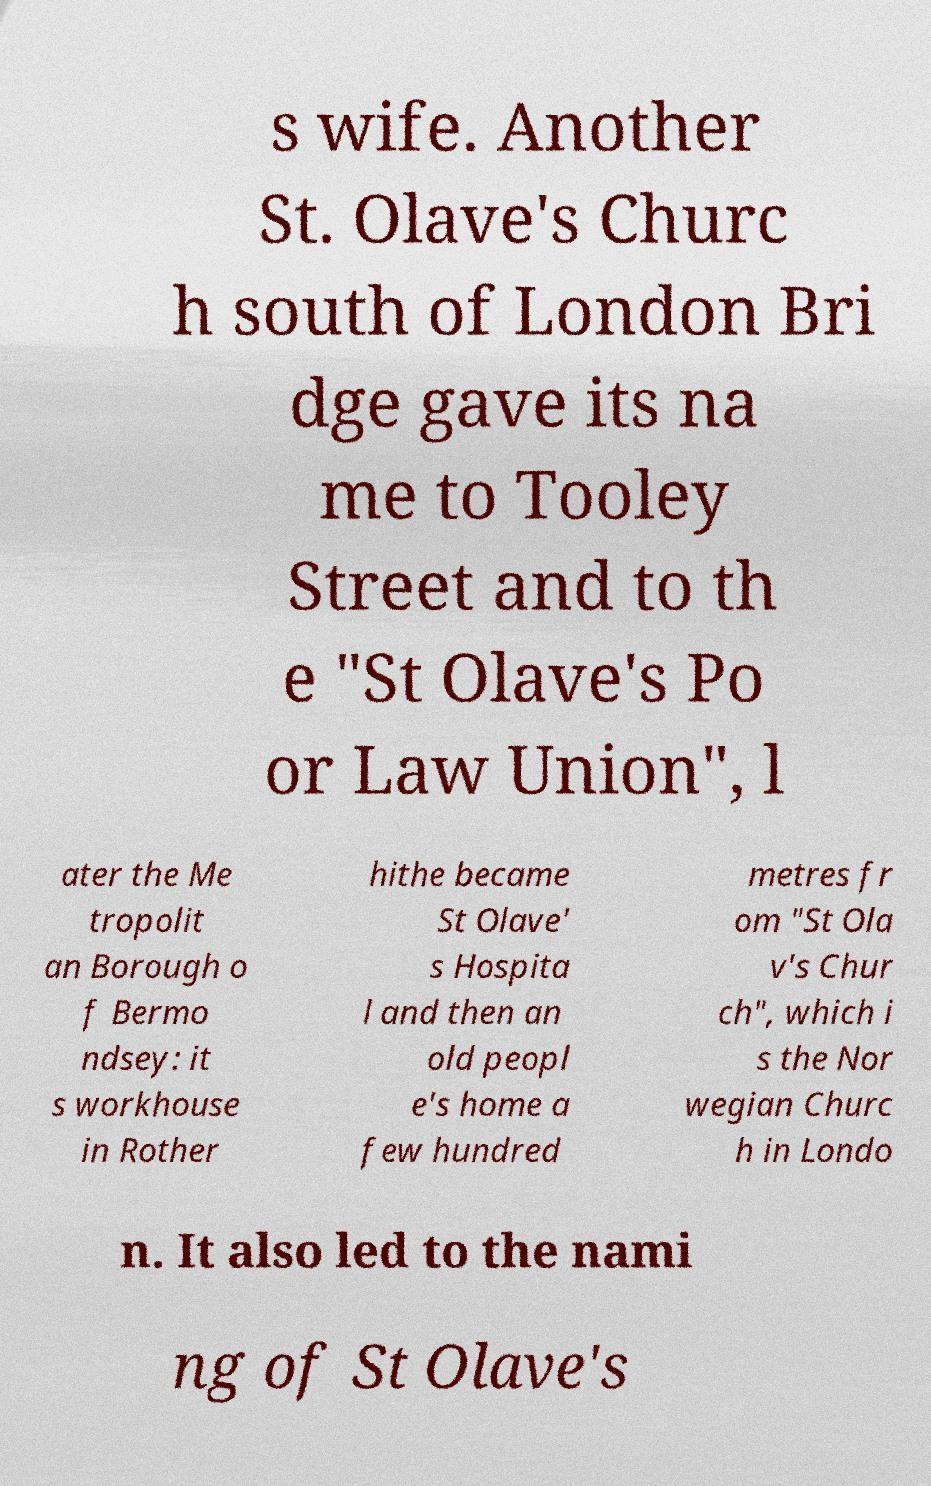Please identify and transcribe the text found in this image. s wife. Another St. Olave's Churc h south of London Bri dge gave its na me to Tooley Street and to th e "St Olave's Po or Law Union", l ater the Me tropolit an Borough o f Bermo ndsey: it s workhouse in Rother hithe became St Olave' s Hospita l and then an old peopl e's home a few hundred metres fr om "St Ola v's Chur ch", which i s the Nor wegian Churc h in Londo n. It also led to the nami ng of St Olave's 